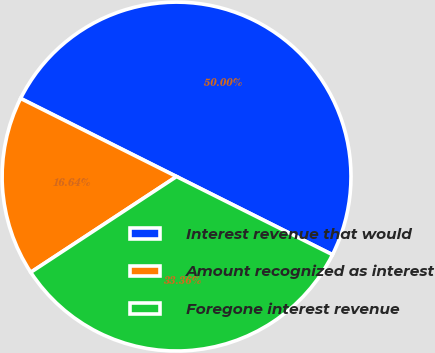<chart> <loc_0><loc_0><loc_500><loc_500><pie_chart><fcel>Interest revenue that would<fcel>Amount recognized as interest<fcel>Foregone interest revenue<nl><fcel>50.0%<fcel>16.64%<fcel>33.36%<nl></chart> 